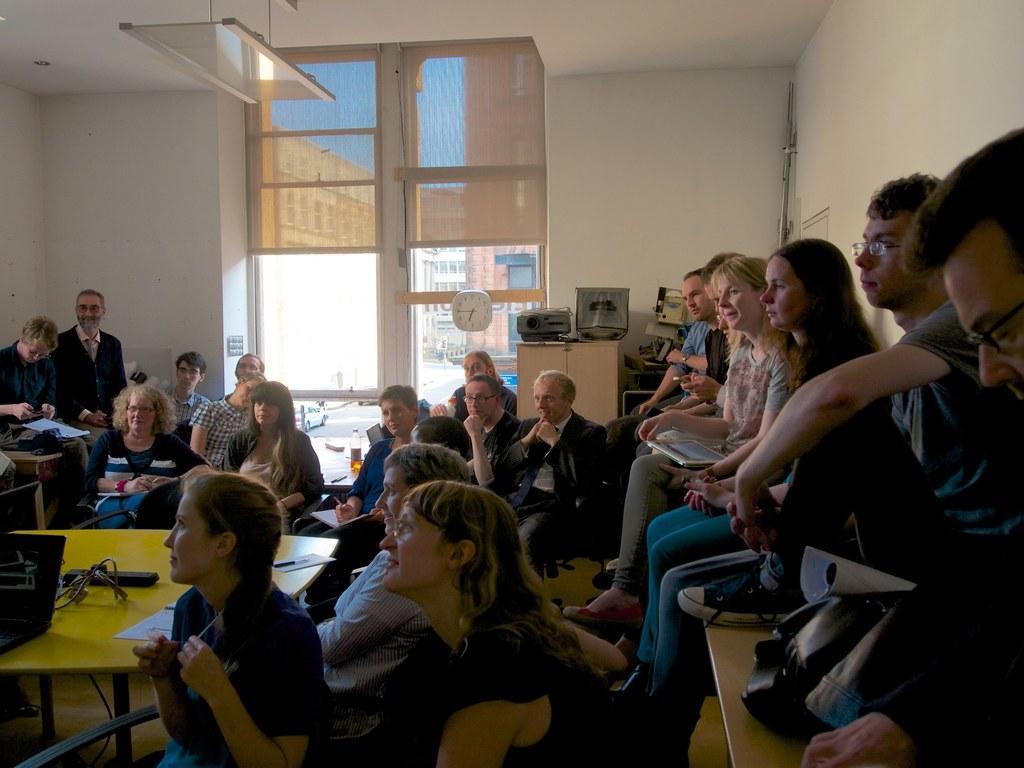In one or two sentences, can you explain what this image depicts? In this image we can see a group of persons sitting on the chairs. On the left side there is a table, laptop and plug box. In the background there is a building, door, clock, projector, car, buildings and sky. 